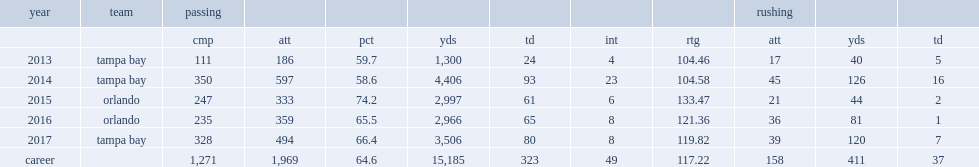How many yards did randy hippeard throw for in 2017? 3506.0. How many touchdowns did randy hippeard throw for in 2017? 80.0. 